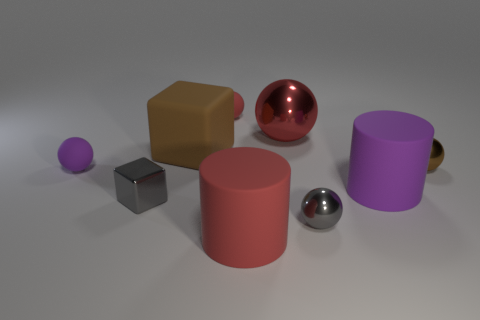How many spheres are to the left of the red cylinder and behind the large matte cube?
Offer a terse response. 1. The sphere that is left of the large brown matte block behind the big purple rubber cylinder is what color?
Ensure brevity in your answer.  Purple. Are there the same number of cylinders right of the big purple object and big cyan metal cylinders?
Ensure brevity in your answer.  Yes. There is a large purple thing in front of the red matte sphere behind the gray metal cube; how many tiny gray spheres are left of it?
Give a very brief answer. 1. What is the color of the small rubber object that is in front of the brown matte cube?
Provide a short and direct response. Purple. There is a thing that is in front of the tiny gray cube and behind the large red matte cylinder; what material is it made of?
Make the answer very short. Metal. There is a tiny ball to the left of the big brown object; how many objects are in front of it?
Keep it short and to the point. 4. What is the shape of the big brown matte object?
Your response must be concise. Cube. What is the shape of the big purple object that is made of the same material as the purple sphere?
Your response must be concise. Cylinder. Does the purple object that is on the left side of the small red rubber object have the same shape as the big brown thing?
Provide a short and direct response. No. 